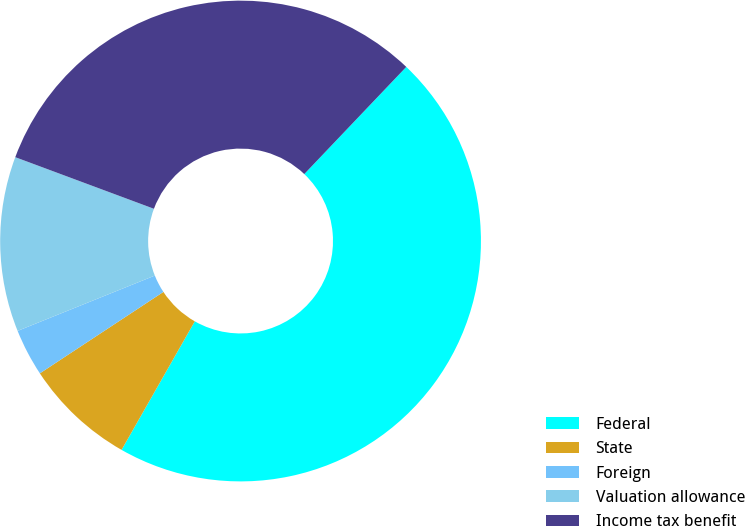<chart> <loc_0><loc_0><loc_500><loc_500><pie_chart><fcel>Federal<fcel>State<fcel>Foreign<fcel>Valuation allowance<fcel>Income tax benefit<nl><fcel>46.14%<fcel>7.48%<fcel>3.18%<fcel>11.77%<fcel>31.44%<nl></chart> 